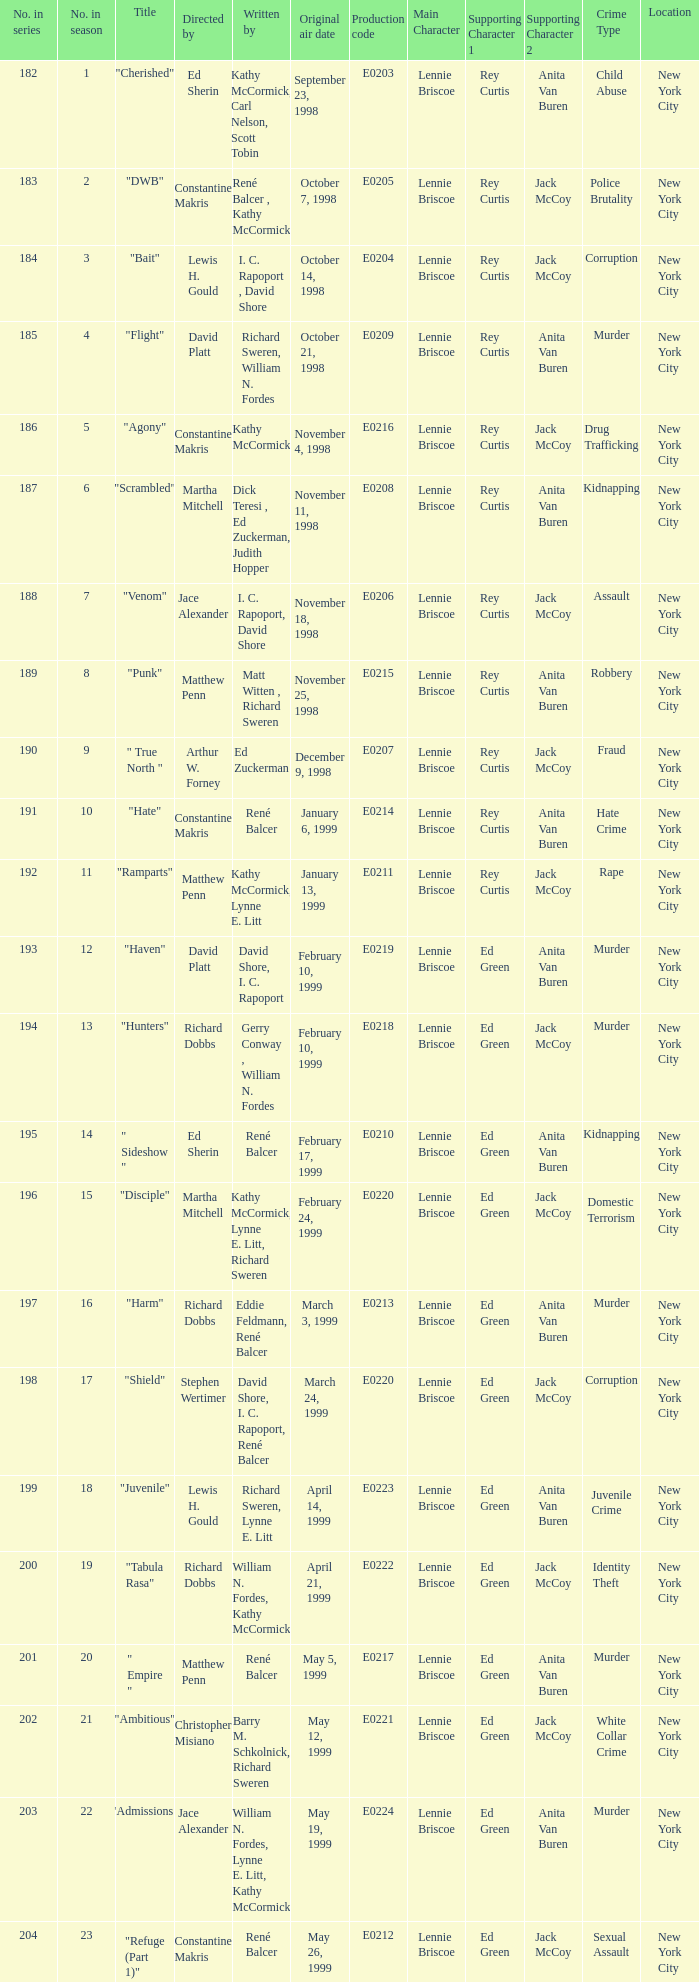The episode with original air date January 13, 1999 is written by who? Kathy McCormick, Lynne E. Litt. 